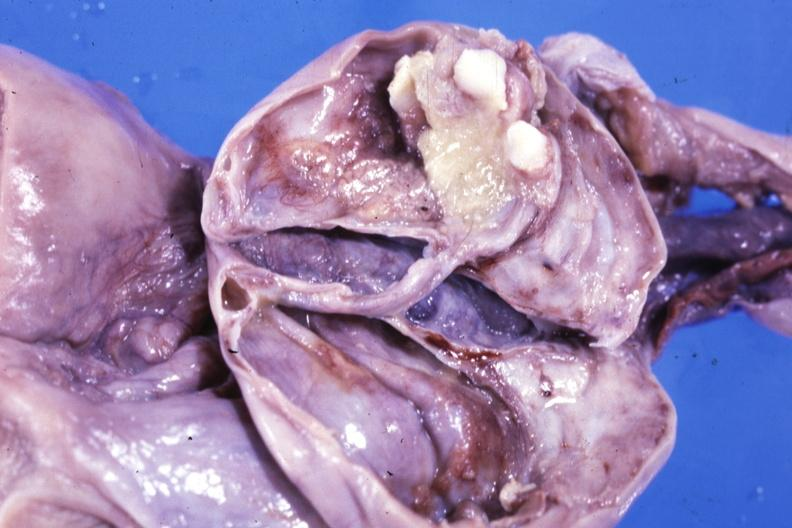what is fixed tissue opened?
Answer the question using a single word or phrase. Ovarian cyst with two or three teeth 